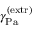<formula> <loc_0><loc_0><loc_500><loc_500>\gamma _ { P a } ^ { ( e x t r ) }</formula> 